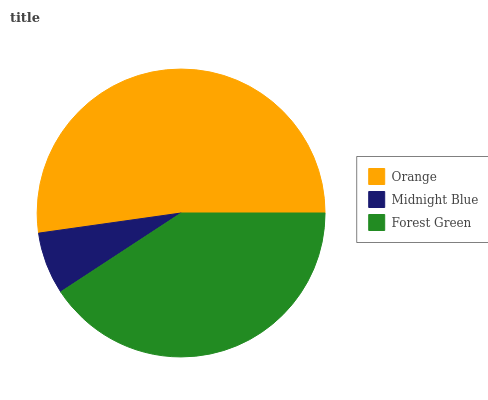Is Midnight Blue the minimum?
Answer yes or no. Yes. Is Orange the maximum?
Answer yes or no. Yes. Is Forest Green the minimum?
Answer yes or no. No. Is Forest Green the maximum?
Answer yes or no. No. Is Forest Green greater than Midnight Blue?
Answer yes or no. Yes. Is Midnight Blue less than Forest Green?
Answer yes or no. Yes. Is Midnight Blue greater than Forest Green?
Answer yes or no. No. Is Forest Green less than Midnight Blue?
Answer yes or no. No. Is Forest Green the high median?
Answer yes or no. Yes. Is Forest Green the low median?
Answer yes or no. Yes. Is Midnight Blue the high median?
Answer yes or no. No. Is Midnight Blue the low median?
Answer yes or no. No. 